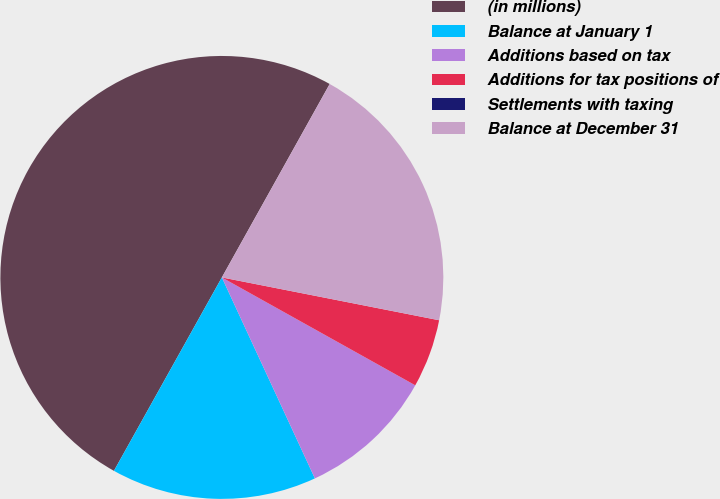Convert chart. <chart><loc_0><loc_0><loc_500><loc_500><pie_chart><fcel>(in millions)<fcel>Balance at January 1<fcel>Additions based on tax<fcel>Additions for tax positions of<fcel>Settlements with taxing<fcel>Balance at December 31<nl><fcel>49.99%<fcel>15.0%<fcel>10.0%<fcel>5.0%<fcel>0.0%<fcel>20.0%<nl></chart> 